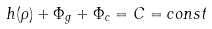<formula> <loc_0><loc_0><loc_500><loc_500>h ( \rho ) + \Phi _ { g } + \Phi _ { c } = C = c o n s t</formula> 